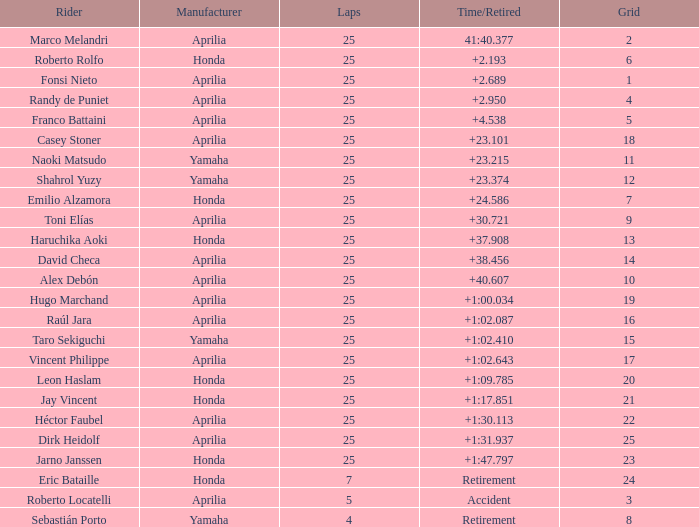Which grid includes 25 laps, a honda producer, and a time/retired of +1:4 23.0. 